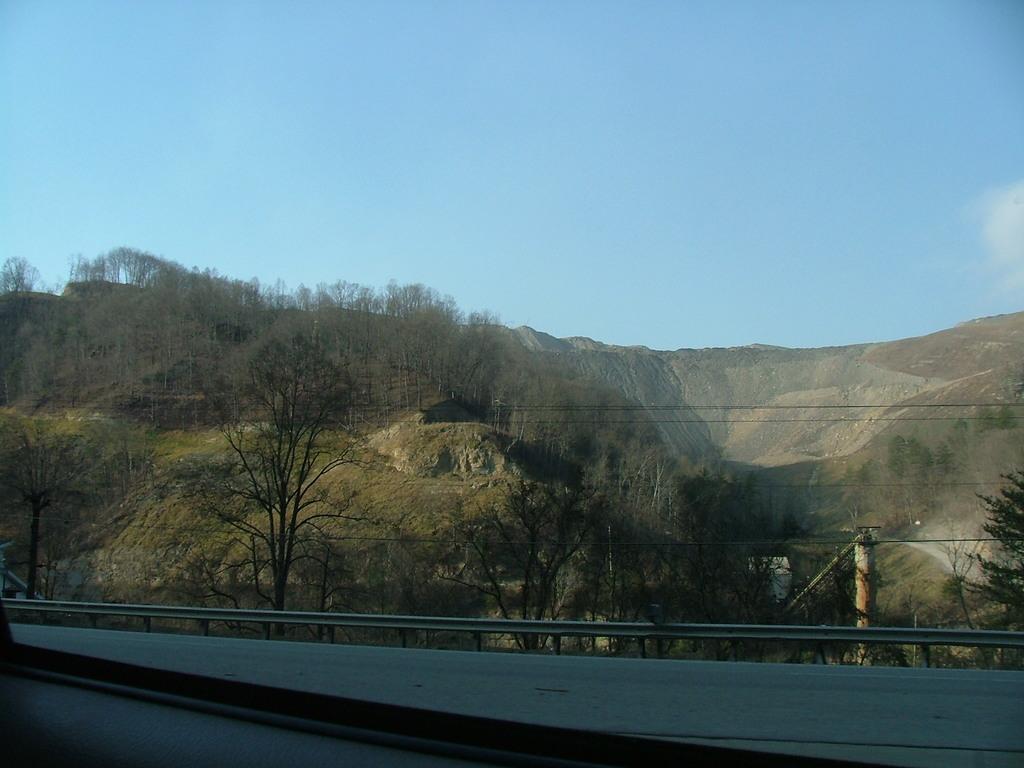How would you summarize this image in a sentence or two? In the image we can see there are many trees, mountain, grass, electric pole, electric wire and a pale blue sky. This is a barrier. 